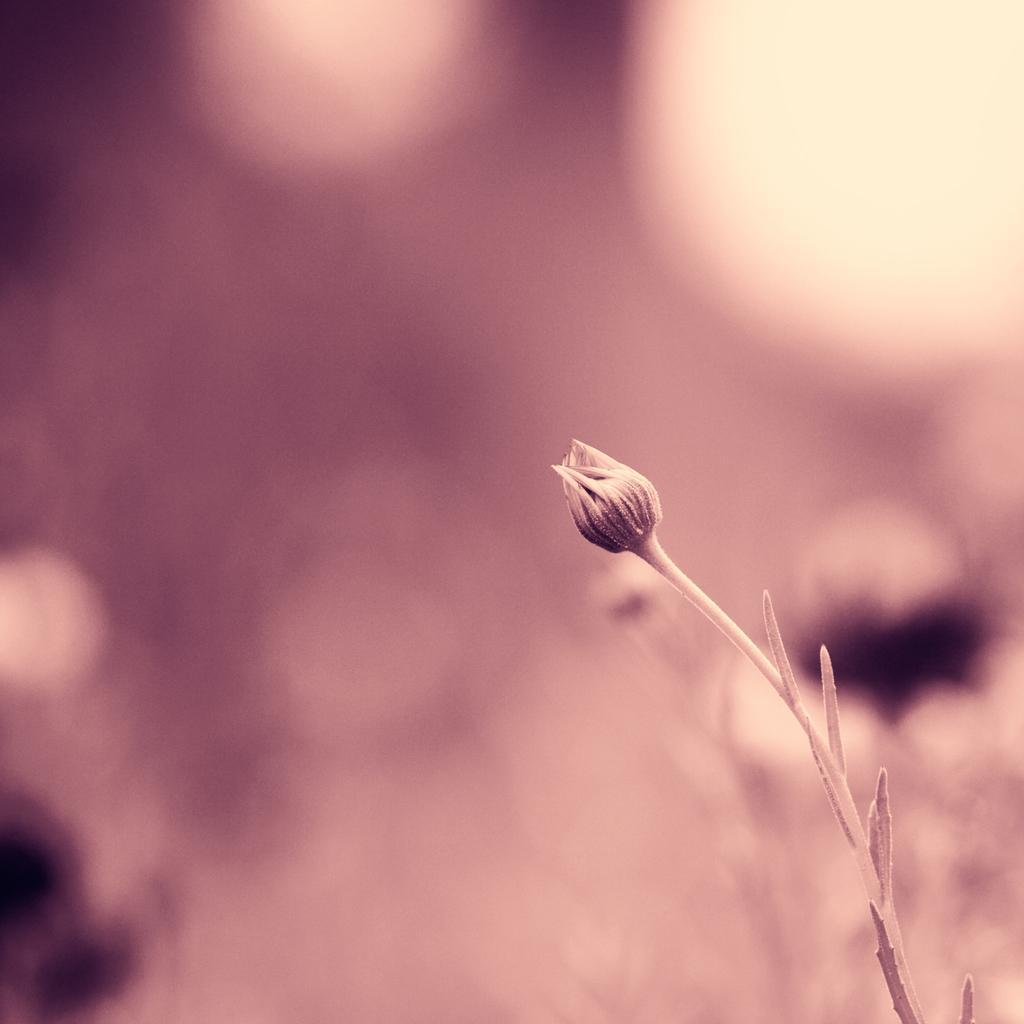In one or two sentences, can you explain what this image depicts? In this image I can see a bug which is in pink color. Background is in pink and cream color. 